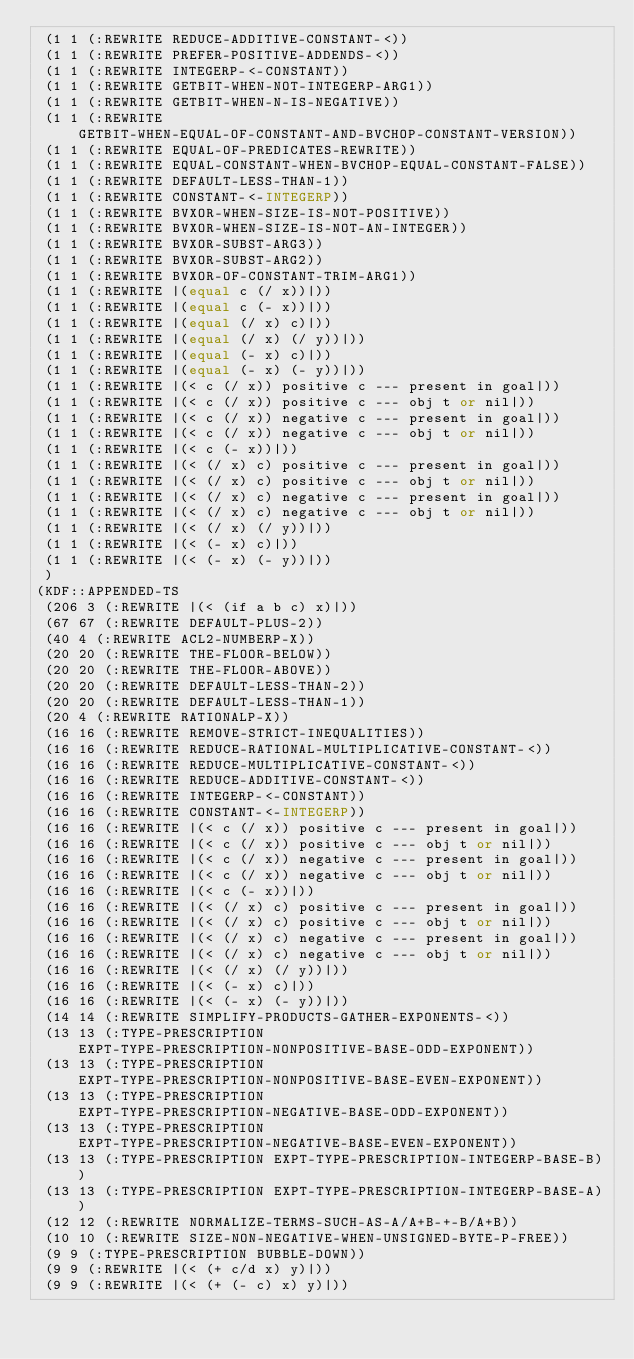Convert code to text. <code><loc_0><loc_0><loc_500><loc_500><_Lisp_> (1 1 (:REWRITE REDUCE-ADDITIVE-CONSTANT-<))
 (1 1 (:REWRITE PREFER-POSITIVE-ADDENDS-<))
 (1 1 (:REWRITE INTEGERP-<-CONSTANT))
 (1 1 (:REWRITE GETBIT-WHEN-NOT-INTEGERP-ARG1))
 (1 1 (:REWRITE GETBIT-WHEN-N-IS-NEGATIVE))
 (1 1 (:REWRITE GETBIT-WHEN-EQUAL-OF-CONSTANT-AND-BVCHOP-CONSTANT-VERSION))
 (1 1 (:REWRITE EQUAL-OF-PREDICATES-REWRITE))
 (1 1 (:REWRITE EQUAL-CONSTANT-WHEN-BVCHOP-EQUAL-CONSTANT-FALSE))
 (1 1 (:REWRITE DEFAULT-LESS-THAN-1))
 (1 1 (:REWRITE CONSTANT-<-INTEGERP))
 (1 1 (:REWRITE BVXOR-WHEN-SIZE-IS-NOT-POSITIVE))
 (1 1 (:REWRITE BVXOR-WHEN-SIZE-IS-NOT-AN-INTEGER))
 (1 1 (:REWRITE BVXOR-SUBST-ARG3))
 (1 1 (:REWRITE BVXOR-SUBST-ARG2))
 (1 1 (:REWRITE BVXOR-OF-CONSTANT-TRIM-ARG1))
 (1 1 (:REWRITE |(equal c (/ x))|))
 (1 1 (:REWRITE |(equal c (- x))|))
 (1 1 (:REWRITE |(equal (/ x) c)|))
 (1 1 (:REWRITE |(equal (/ x) (/ y))|))
 (1 1 (:REWRITE |(equal (- x) c)|))
 (1 1 (:REWRITE |(equal (- x) (- y))|))
 (1 1 (:REWRITE |(< c (/ x)) positive c --- present in goal|))
 (1 1 (:REWRITE |(< c (/ x)) positive c --- obj t or nil|))
 (1 1 (:REWRITE |(< c (/ x)) negative c --- present in goal|))
 (1 1 (:REWRITE |(< c (/ x)) negative c --- obj t or nil|))
 (1 1 (:REWRITE |(< c (- x))|))
 (1 1 (:REWRITE |(< (/ x) c) positive c --- present in goal|))
 (1 1 (:REWRITE |(< (/ x) c) positive c --- obj t or nil|))
 (1 1 (:REWRITE |(< (/ x) c) negative c --- present in goal|))
 (1 1 (:REWRITE |(< (/ x) c) negative c --- obj t or nil|))
 (1 1 (:REWRITE |(< (/ x) (/ y))|))
 (1 1 (:REWRITE |(< (- x) c)|))
 (1 1 (:REWRITE |(< (- x) (- y))|))
 )
(KDF::APPENDED-TS
 (206 3 (:REWRITE |(< (if a b c) x)|))
 (67 67 (:REWRITE DEFAULT-PLUS-2))
 (40 4 (:REWRITE ACL2-NUMBERP-X))
 (20 20 (:REWRITE THE-FLOOR-BELOW))
 (20 20 (:REWRITE THE-FLOOR-ABOVE))
 (20 20 (:REWRITE DEFAULT-LESS-THAN-2))
 (20 20 (:REWRITE DEFAULT-LESS-THAN-1))
 (20 4 (:REWRITE RATIONALP-X))
 (16 16 (:REWRITE REMOVE-STRICT-INEQUALITIES))
 (16 16 (:REWRITE REDUCE-RATIONAL-MULTIPLICATIVE-CONSTANT-<))
 (16 16 (:REWRITE REDUCE-MULTIPLICATIVE-CONSTANT-<))
 (16 16 (:REWRITE REDUCE-ADDITIVE-CONSTANT-<))
 (16 16 (:REWRITE INTEGERP-<-CONSTANT))
 (16 16 (:REWRITE CONSTANT-<-INTEGERP))
 (16 16 (:REWRITE |(< c (/ x)) positive c --- present in goal|))
 (16 16 (:REWRITE |(< c (/ x)) positive c --- obj t or nil|))
 (16 16 (:REWRITE |(< c (/ x)) negative c --- present in goal|))
 (16 16 (:REWRITE |(< c (/ x)) negative c --- obj t or nil|))
 (16 16 (:REWRITE |(< c (- x))|))
 (16 16 (:REWRITE |(< (/ x) c) positive c --- present in goal|))
 (16 16 (:REWRITE |(< (/ x) c) positive c --- obj t or nil|))
 (16 16 (:REWRITE |(< (/ x) c) negative c --- present in goal|))
 (16 16 (:REWRITE |(< (/ x) c) negative c --- obj t or nil|))
 (16 16 (:REWRITE |(< (/ x) (/ y))|))
 (16 16 (:REWRITE |(< (- x) c)|))
 (16 16 (:REWRITE |(< (- x) (- y))|))
 (14 14 (:REWRITE SIMPLIFY-PRODUCTS-GATHER-EXPONENTS-<))
 (13 13 (:TYPE-PRESCRIPTION EXPT-TYPE-PRESCRIPTION-NONPOSITIVE-BASE-ODD-EXPONENT))
 (13 13 (:TYPE-PRESCRIPTION EXPT-TYPE-PRESCRIPTION-NONPOSITIVE-BASE-EVEN-EXPONENT))
 (13 13 (:TYPE-PRESCRIPTION EXPT-TYPE-PRESCRIPTION-NEGATIVE-BASE-ODD-EXPONENT))
 (13 13 (:TYPE-PRESCRIPTION EXPT-TYPE-PRESCRIPTION-NEGATIVE-BASE-EVEN-EXPONENT))
 (13 13 (:TYPE-PRESCRIPTION EXPT-TYPE-PRESCRIPTION-INTEGERP-BASE-B))
 (13 13 (:TYPE-PRESCRIPTION EXPT-TYPE-PRESCRIPTION-INTEGERP-BASE-A))
 (12 12 (:REWRITE NORMALIZE-TERMS-SUCH-AS-A/A+B-+-B/A+B))
 (10 10 (:REWRITE SIZE-NON-NEGATIVE-WHEN-UNSIGNED-BYTE-P-FREE))
 (9 9 (:TYPE-PRESCRIPTION BUBBLE-DOWN))
 (9 9 (:REWRITE |(< (+ c/d x) y)|))
 (9 9 (:REWRITE |(< (+ (- c) x) y)|))</code> 